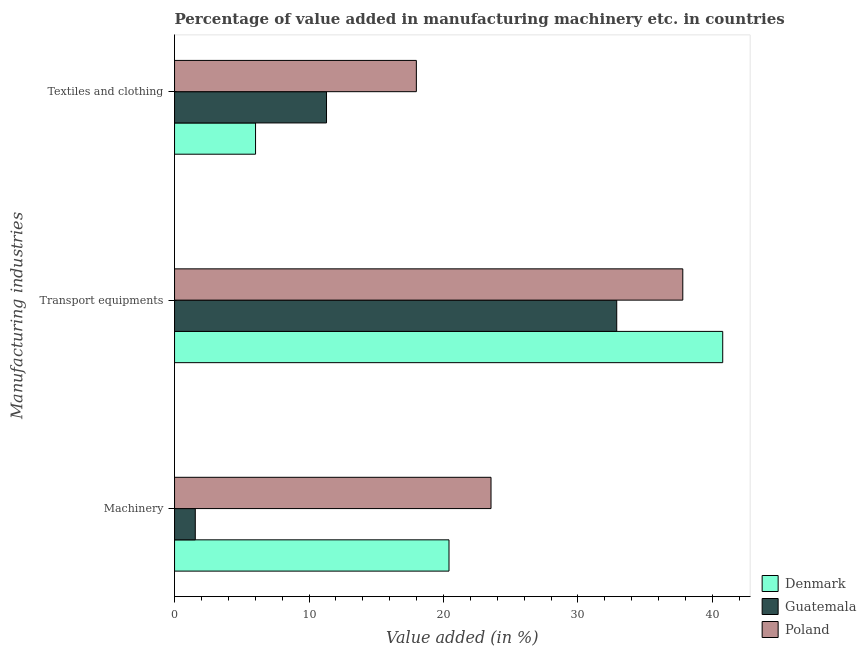How many different coloured bars are there?
Your answer should be compact. 3. Are the number of bars per tick equal to the number of legend labels?
Keep it short and to the point. Yes. How many bars are there on the 1st tick from the top?
Keep it short and to the point. 3. What is the label of the 3rd group of bars from the top?
Keep it short and to the point. Machinery. What is the value added in manufacturing textile and clothing in Poland?
Ensure brevity in your answer.  17.98. Across all countries, what is the maximum value added in manufacturing transport equipments?
Your answer should be compact. 40.76. Across all countries, what is the minimum value added in manufacturing transport equipments?
Your answer should be very brief. 32.88. In which country was the value added in manufacturing transport equipments maximum?
Keep it short and to the point. Denmark. In which country was the value added in manufacturing machinery minimum?
Ensure brevity in your answer.  Guatemala. What is the total value added in manufacturing transport equipments in the graph?
Your answer should be very brief. 111.44. What is the difference between the value added in manufacturing textile and clothing in Denmark and that in Guatemala?
Make the answer very short. -5.28. What is the difference between the value added in manufacturing machinery in Guatemala and the value added in manufacturing textile and clothing in Poland?
Your answer should be compact. -16.44. What is the average value added in manufacturing textile and clothing per country?
Offer a very short reply. 11.77. What is the difference between the value added in manufacturing machinery and value added in manufacturing textile and clothing in Poland?
Offer a terse response. 5.55. In how many countries, is the value added in manufacturing transport equipments greater than 20 %?
Make the answer very short. 3. What is the ratio of the value added in manufacturing transport equipments in Guatemala to that in Poland?
Your answer should be compact. 0.87. What is the difference between the highest and the second highest value added in manufacturing textile and clothing?
Offer a very short reply. 6.68. What is the difference between the highest and the lowest value added in manufacturing transport equipments?
Provide a short and direct response. 7.88. In how many countries, is the value added in manufacturing machinery greater than the average value added in manufacturing machinery taken over all countries?
Your response must be concise. 2. Is the sum of the value added in manufacturing textile and clothing in Denmark and Poland greater than the maximum value added in manufacturing machinery across all countries?
Make the answer very short. Yes. What does the 1st bar from the top in Machinery represents?
Make the answer very short. Poland. Is it the case that in every country, the sum of the value added in manufacturing machinery and value added in manufacturing transport equipments is greater than the value added in manufacturing textile and clothing?
Offer a terse response. Yes. How many bars are there?
Keep it short and to the point. 9. Are the values on the major ticks of X-axis written in scientific E-notation?
Your answer should be compact. No. How many legend labels are there?
Provide a short and direct response. 3. How are the legend labels stacked?
Provide a succinct answer. Vertical. What is the title of the graph?
Provide a succinct answer. Percentage of value added in manufacturing machinery etc. in countries. What is the label or title of the X-axis?
Make the answer very short. Value added (in %). What is the label or title of the Y-axis?
Your answer should be compact. Manufacturing industries. What is the Value added (in %) of Denmark in Machinery?
Your answer should be compact. 20.41. What is the Value added (in %) in Guatemala in Machinery?
Your answer should be very brief. 1.54. What is the Value added (in %) in Poland in Machinery?
Keep it short and to the point. 23.53. What is the Value added (in %) of Denmark in Transport equipments?
Give a very brief answer. 40.76. What is the Value added (in %) in Guatemala in Transport equipments?
Keep it short and to the point. 32.88. What is the Value added (in %) in Poland in Transport equipments?
Provide a succinct answer. 37.79. What is the Value added (in %) of Denmark in Textiles and clothing?
Make the answer very short. 6.02. What is the Value added (in %) of Guatemala in Textiles and clothing?
Your answer should be compact. 11.3. What is the Value added (in %) of Poland in Textiles and clothing?
Keep it short and to the point. 17.98. Across all Manufacturing industries, what is the maximum Value added (in %) in Denmark?
Provide a succinct answer. 40.76. Across all Manufacturing industries, what is the maximum Value added (in %) in Guatemala?
Keep it short and to the point. 32.88. Across all Manufacturing industries, what is the maximum Value added (in %) of Poland?
Provide a short and direct response. 37.79. Across all Manufacturing industries, what is the minimum Value added (in %) in Denmark?
Your answer should be compact. 6.02. Across all Manufacturing industries, what is the minimum Value added (in %) of Guatemala?
Your response must be concise. 1.54. Across all Manufacturing industries, what is the minimum Value added (in %) in Poland?
Your response must be concise. 17.98. What is the total Value added (in %) in Denmark in the graph?
Offer a terse response. 67.19. What is the total Value added (in %) of Guatemala in the graph?
Provide a short and direct response. 45.72. What is the total Value added (in %) in Poland in the graph?
Ensure brevity in your answer.  79.31. What is the difference between the Value added (in %) of Denmark in Machinery and that in Transport equipments?
Ensure brevity in your answer.  -20.35. What is the difference between the Value added (in %) of Guatemala in Machinery and that in Transport equipments?
Provide a succinct answer. -31.34. What is the difference between the Value added (in %) of Poland in Machinery and that in Transport equipments?
Offer a terse response. -14.26. What is the difference between the Value added (in %) of Denmark in Machinery and that in Textiles and clothing?
Keep it short and to the point. 14.39. What is the difference between the Value added (in %) of Guatemala in Machinery and that in Textiles and clothing?
Your answer should be very brief. -9.76. What is the difference between the Value added (in %) in Poland in Machinery and that in Textiles and clothing?
Keep it short and to the point. 5.55. What is the difference between the Value added (in %) in Denmark in Transport equipments and that in Textiles and clothing?
Give a very brief answer. 34.74. What is the difference between the Value added (in %) in Guatemala in Transport equipments and that in Textiles and clothing?
Your answer should be very brief. 21.58. What is the difference between the Value added (in %) of Poland in Transport equipments and that in Textiles and clothing?
Keep it short and to the point. 19.81. What is the difference between the Value added (in %) of Denmark in Machinery and the Value added (in %) of Guatemala in Transport equipments?
Provide a succinct answer. -12.47. What is the difference between the Value added (in %) in Denmark in Machinery and the Value added (in %) in Poland in Transport equipments?
Give a very brief answer. -17.39. What is the difference between the Value added (in %) in Guatemala in Machinery and the Value added (in %) in Poland in Transport equipments?
Give a very brief answer. -36.25. What is the difference between the Value added (in %) of Denmark in Machinery and the Value added (in %) of Guatemala in Textiles and clothing?
Ensure brevity in your answer.  9.11. What is the difference between the Value added (in %) of Denmark in Machinery and the Value added (in %) of Poland in Textiles and clothing?
Your response must be concise. 2.43. What is the difference between the Value added (in %) in Guatemala in Machinery and the Value added (in %) in Poland in Textiles and clothing?
Provide a succinct answer. -16.44. What is the difference between the Value added (in %) in Denmark in Transport equipments and the Value added (in %) in Guatemala in Textiles and clothing?
Ensure brevity in your answer.  29.46. What is the difference between the Value added (in %) of Denmark in Transport equipments and the Value added (in %) of Poland in Textiles and clothing?
Offer a terse response. 22.78. What is the difference between the Value added (in %) in Guatemala in Transport equipments and the Value added (in %) in Poland in Textiles and clothing?
Ensure brevity in your answer.  14.9. What is the average Value added (in %) in Denmark per Manufacturing industries?
Keep it short and to the point. 22.4. What is the average Value added (in %) in Guatemala per Manufacturing industries?
Make the answer very short. 15.24. What is the average Value added (in %) of Poland per Manufacturing industries?
Your answer should be compact. 26.44. What is the difference between the Value added (in %) of Denmark and Value added (in %) of Guatemala in Machinery?
Provide a short and direct response. 18.87. What is the difference between the Value added (in %) in Denmark and Value added (in %) in Poland in Machinery?
Give a very brief answer. -3.12. What is the difference between the Value added (in %) in Guatemala and Value added (in %) in Poland in Machinery?
Provide a succinct answer. -21.99. What is the difference between the Value added (in %) in Denmark and Value added (in %) in Guatemala in Transport equipments?
Keep it short and to the point. 7.88. What is the difference between the Value added (in %) of Denmark and Value added (in %) of Poland in Transport equipments?
Offer a terse response. 2.97. What is the difference between the Value added (in %) of Guatemala and Value added (in %) of Poland in Transport equipments?
Provide a short and direct response. -4.91. What is the difference between the Value added (in %) of Denmark and Value added (in %) of Guatemala in Textiles and clothing?
Offer a terse response. -5.28. What is the difference between the Value added (in %) in Denmark and Value added (in %) in Poland in Textiles and clothing?
Offer a terse response. -11.96. What is the difference between the Value added (in %) of Guatemala and Value added (in %) of Poland in Textiles and clothing?
Your answer should be compact. -6.68. What is the ratio of the Value added (in %) in Denmark in Machinery to that in Transport equipments?
Keep it short and to the point. 0.5. What is the ratio of the Value added (in %) in Guatemala in Machinery to that in Transport equipments?
Provide a succinct answer. 0.05. What is the ratio of the Value added (in %) in Poland in Machinery to that in Transport equipments?
Make the answer very short. 0.62. What is the ratio of the Value added (in %) in Denmark in Machinery to that in Textiles and clothing?
Ensure brevity in your answer.  3.39. What is the ratio of the Value added (in %) in Guatemala in Machinery to that in Textiles and clothing?
Your response must be concise. 0.14. What is the ratio of the Value added (in %) in Poland in Machinery to that in Textiles and clothing?
Your answer should be compact. 1.31. What is the ratio of the Value added (in %) in Denmark in Transport equipments to that in Textiles and clothing?
Ensure brevity in your answer.  6.77. What is the ratio of the Value added (in %) in Guatemala in Transport equipments to that in Textiles and clothing?
Make the answer very short. 2.91. What is the ratio of the Value added (in %) of Poland in Transport equipments to that in Textiles and clothing?
Provide a short and direct response. 2.1. What is the difference between the highest and the second highest Value added (in %) of Denmark?
Give a very brief answer. 20.35. What is the difference between the highest and the second highest Value added (in %) in Guatemala?
Your answer should be compact. 21.58. What is the difference between the highest and the second highest Value added (in %) of Poland?
Your answer should be very brief. 14.26. What is the difference between the highest and the lowest Value added (in %) in Denmark?
Your answer should be very brief. 34.74. What is the difference between the highest and the lowest Value added (in %) of Guatemala?
Make the answer very short. 31.34. What is the difference between the highest and the lowest Value added (in %) of Poland?
Ensure brevity in your answer.  19.81. 